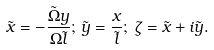<formula> <loc_0><loc_0><loc_500><loc_500>\tilde { x } = - \frac { \tilde { \Omega } y } { \Omega \tilde { l } } ; \, \tilde { y } = \frac { x } { \tilde { l } } ; \, \zeta = \tilde { x } + i \tilde { y } .</formula> 